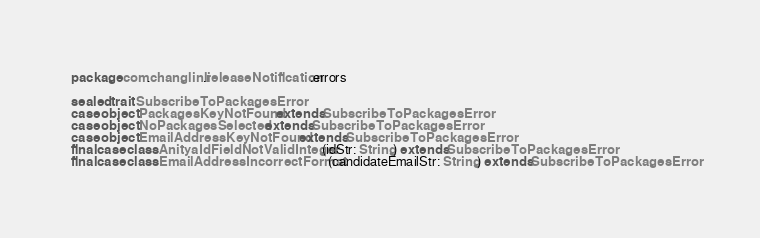Convert code to text. <code><loc_0><loc_0><loc_500><loc_500><_Scala_>package com.changlinli.releaseNotification.errors

sealed trait SubscribeToPackagesError
case object PackagesKeyNotFound extends SubscribeToPackagesError
case object NoPackagesSelected extends SubscribeToPackagesError
case object EmailAddressKeyNotFound extends SubscribeToPackagesError
final case class AnityaIdFieldNotValidInteger(idStr: String) extends SubscribeToPackagesError
final case class EmailAddressIncorrectFormat(candidateEmailStr: String) extends SubscribeToPackagesError
</code> 